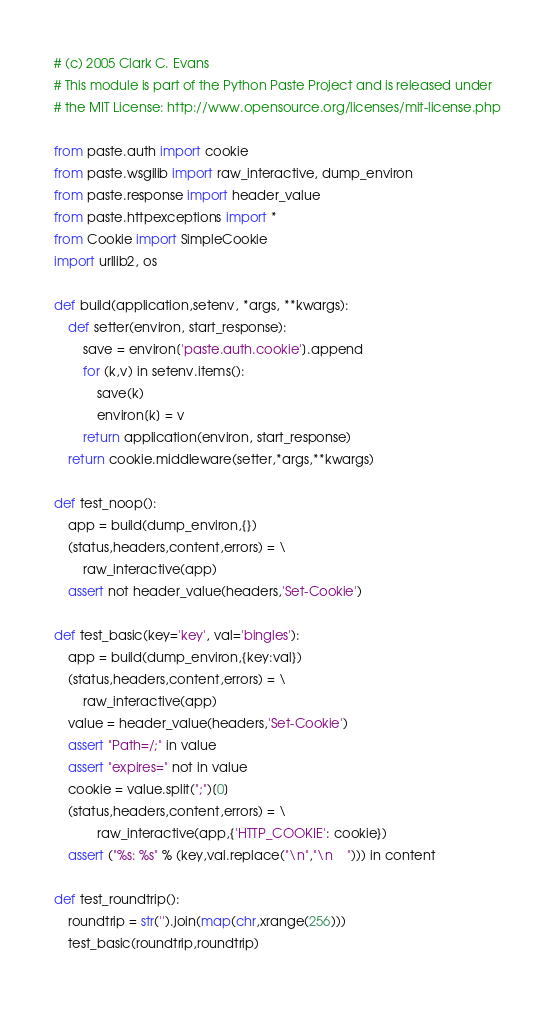Convert code to text. <code><loc_0><loc_0><loc_500><loc_500><_Python_># (c) 2005 Clark C. Evans
# This module is part of the Python Paste Project and is released under
# the MIT License: http://www.opensource.org/licenses/mit-license.php

from paste.auth import cookie
from paste.wsgilib import raw_interactive, dump_environ
from paste.response import header_value
from paste.httpexceptions import *
from Cookie import SimpleCookie
import urllib2, os
        
def build(application,setenv, *args, **kwargs):
    def setter(environ, start_response):
        save = environ['paste.auth.cookie'].append
        for (k,v) in setenv.items():
            save(k)
            environ[k] = v
        return application(environ, start_response)
    return cookie.middleware(setter,*args,**kwargs)

def test_noop():
    app = build(dump_environ,{})
    (status,headers,content,errors) = \
        raw_interactive(app)
    assert not header_value(headers,'Set-Cookie')

def test_basic(key='key', val='bingles'):
    app = build(dump_environ,{key:val})
    (status,headers,content,errors) = \
        raw_interactive(app)
    value = header_value(headers,'Set-Cookie')
    assert "Path=/;" in value
    assert "expires=" not in value
    cookie = value.split(";")[0]
    (status,headers,content,errors) = \
            raw_interactive(app,{'HTTP_COOKIE': cookie})
    assert ("%s: %s" % (key,val.replace("\n","\n    "))) in content

def test_roundtrip():
    roundtrip = str('').join(map(chr,xrange(256)))
    test_basic(roundtrip,roundtrip)

</code> 